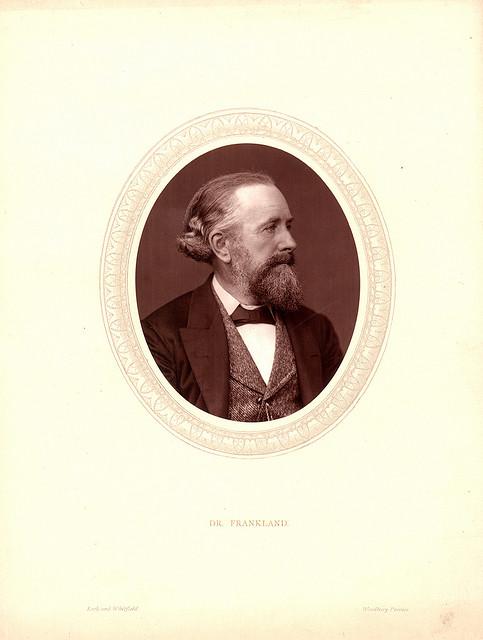Who is in the photo?
Answer briefly. Man. What is shape of picture frame?
Answer briefly. Oval. How old is this photo?
Short answer required. 100 years. 